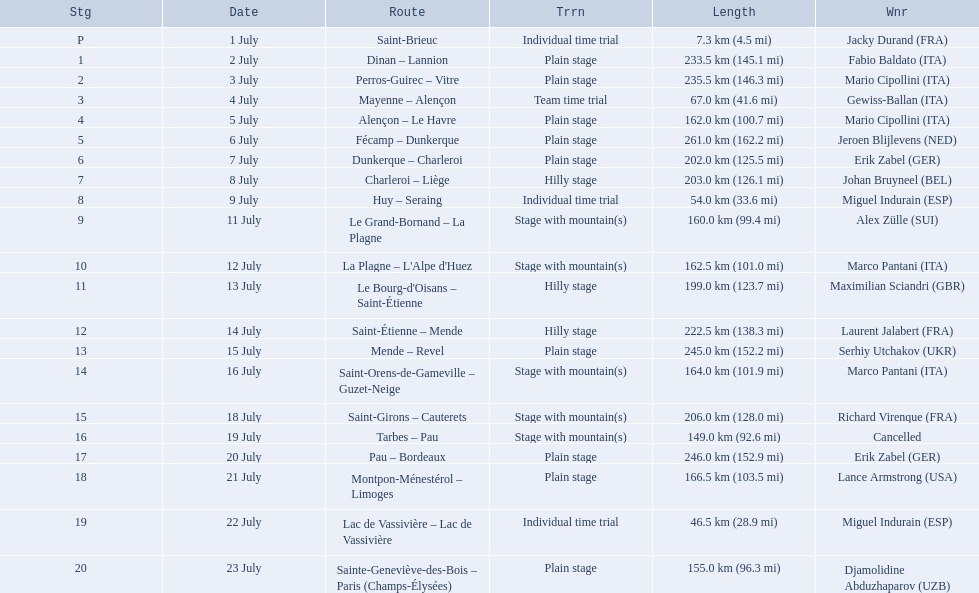What were the lengths of all the stages of the 1995 tour de france? 7.3 km (4.5 mi), 233.5 km (145.1 mi), 235.5 km (146.3 mi), 67.0 km (41.6 mi), 162.0 km (100.7 mi), 261.0 km (162.2 mi), 202.0 km (125.5 mi), 203.0 km (126.1 mi), 54.0 km (33.6 mi), 160.0 km (99.4 mi), 162.5 km (101.0 mi), 199.0 km (123.7 mi), 222.5 km (138.3 mi), 245.0 km (152.2 mi), 164.0 km (101.9 mi), 206.0 km (128.0 mi), 149.0 km (92.6 mi), 246.0 km (152.9 mi), 166.5 km (103.5 mi), 46.5 km (28.9 mi), 155.0 km (96.3 mi). Of those, which one occurred on july 8th? 203.0 km (126.1 mi). 